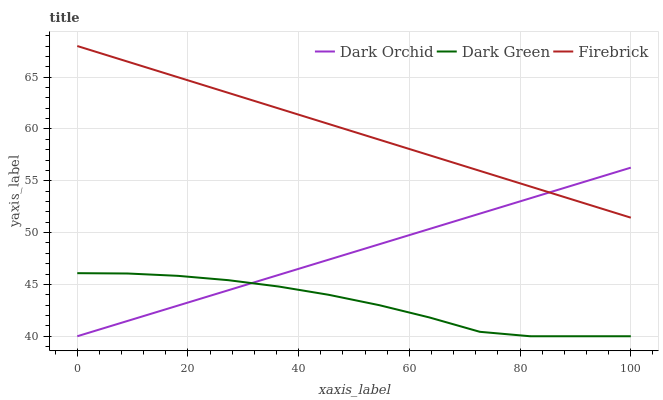Does Dark Green have the minimum area under the curve?
Answer yes or no. Yes. Does Firebrick have the maximum area under the curve?
Answer yes or no. Yes. Does Dark Orchid have the minimum area under the curve?
Answer yes or no. No. Does Dark Orchid have the maximum area under the curve?
Answer yes or no. No. Is Dark Orchid the smoothest?
Answer yes or no. Yes. Is Dark Green the roughest?
Answer yes or no. Yes. Is Dark Green the smoothest?
Answer yes or no. No. Is Dark Orchid the roughest?
Answer yes or no. No. Does Dark Orchid have the lowest value?
Answer yes or no. Yes. Does Firebrick have the highest value?
Answer yes or no. Yes. Does Dark Orchid have the highest value?
Answer yes or no. No. Is Dark Green less than Firebrick?
Answer yes or no. Yes. Is Firebrick greater than Dark Green?
Answer yes or no. Yes. Does Dark Orchid intersect Firebrick?
Answer yes or no. Yes. Is Dark Orchid less than Firebrick?
Answer yes or no. No. Is Dark Orchid greater than Firebrick?
Answer yes or no. No. Does Dark Green intersect Firebrick?
Answer yes or no. No. 